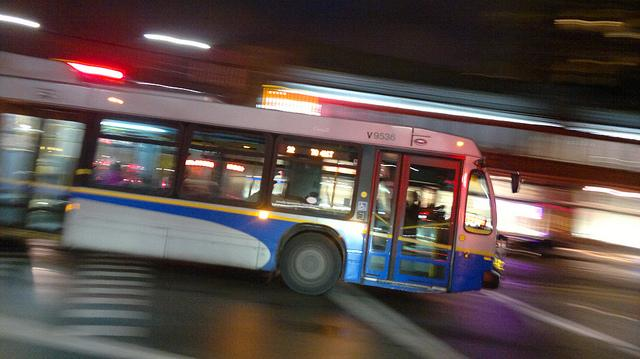Why is the bus blurred in the picture? Please explain your reasoning. moving fast. The shutter setting allows it to be captured in action. 